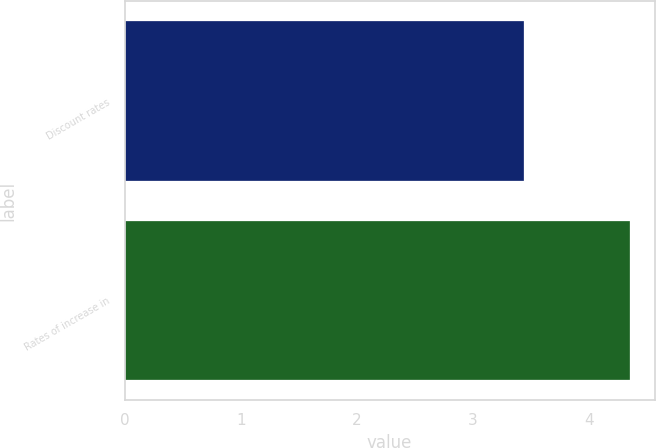Convert chart to OTSL. <chart><loc_0><loc_0><loc_500><loc_500><bar_chart><fcel>Discount rates<fcel>Rates of increase in<nl><fcel>3.44<fcel>4.35<nl></chart> 